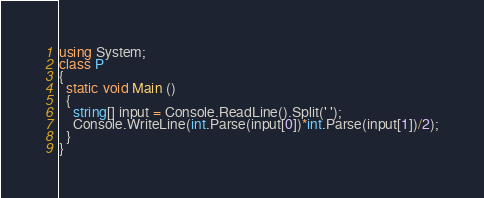Convert code to text. <code><loc_0><loc_0><loc_500><loc_500><_C#_>using System;
class P
{
  static void Main ()
  {
    string[] input = Console.ReadLine().Split(' ');
    Console.WriteLine(int.Parse(input[0])*int.Parse(input[1])/2);
  }
}
</code> 